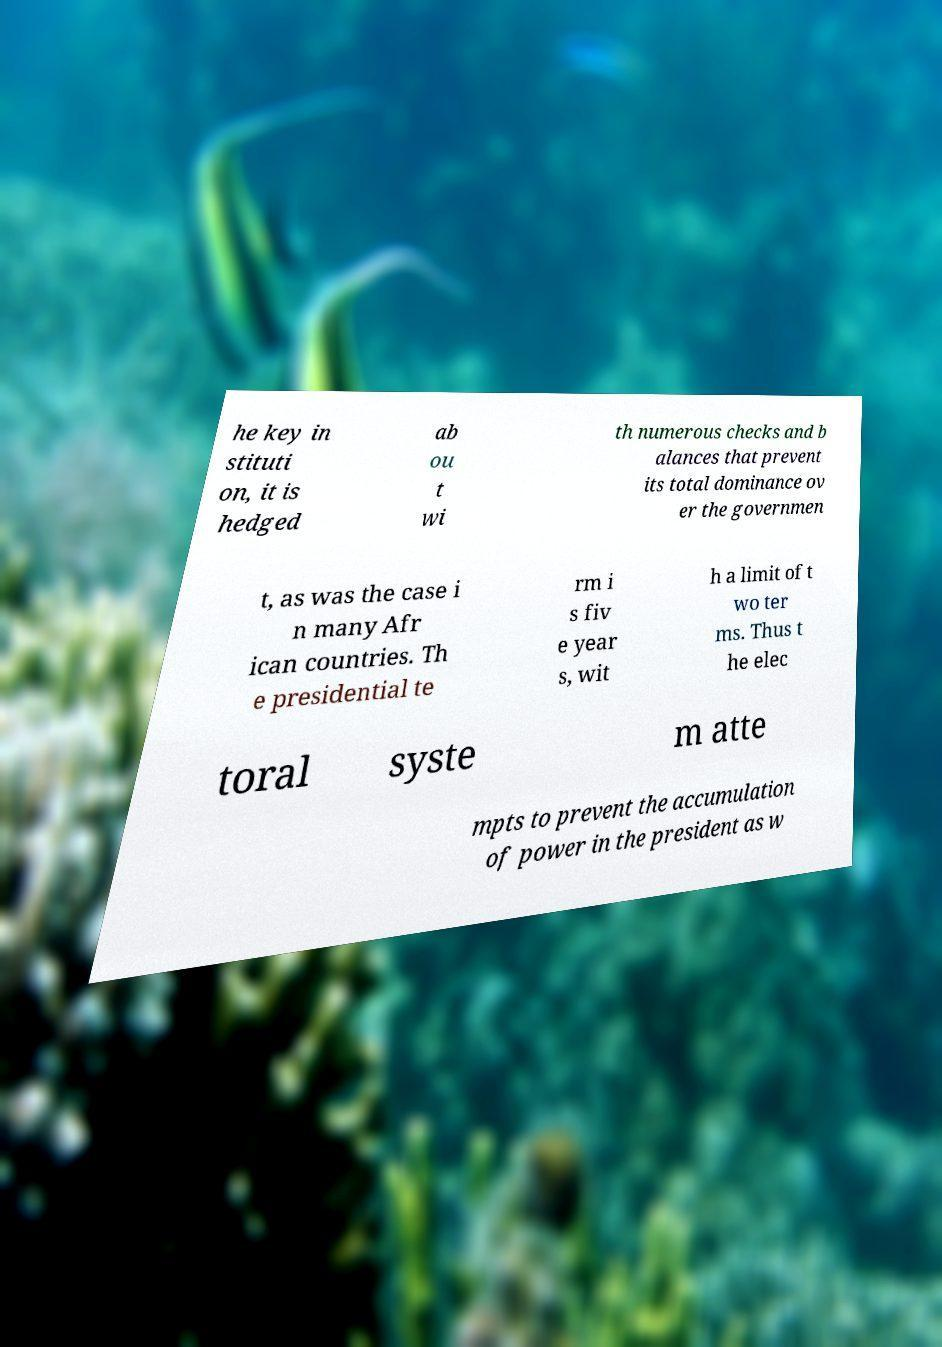I need the written content from this picture converted into text. Can you do that? he key in stituti on, it is hedged ab ou t wi th numerous checks and b alances that prevent its total dominance ov er the governmen t, as was the case i n many Afr ican countries. Th e presidential te rm i s fiv e year s, wit h a limit of t wo ter ms. Thus t he elec toral syste m atte mpts to prevent the accumulation of power in the president as w 